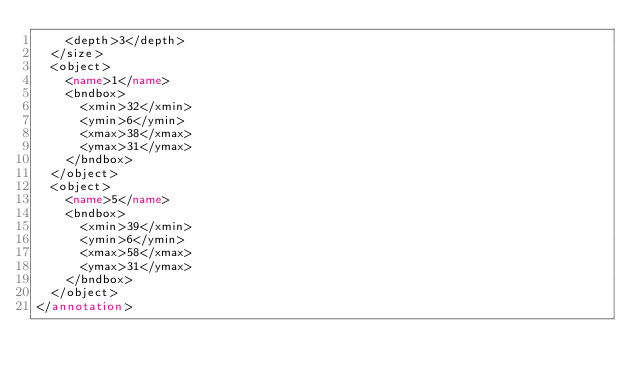Convert code to text. <code><loc_0><loc_0><loc_500><loc_500><_XML_>    <depth>3</depth>
  </size>
  <object>
    <name>1</name>
    <bndbox>
      <xmin>32</xmin>
      <ymin>6</ymin>
      <xmax>38</xmax>
      <ymax>31</ymax>
    </bndbox>
  </object>
  <object>
    <name>5</name>
    <bndbox>
      <xmin>39</xmin>
      <ymin>6</ymin>
      <xmax>58</xmax>
      <ymax>31</ymax>
    </bndbox>
  </object>
</annotation>
</code> 